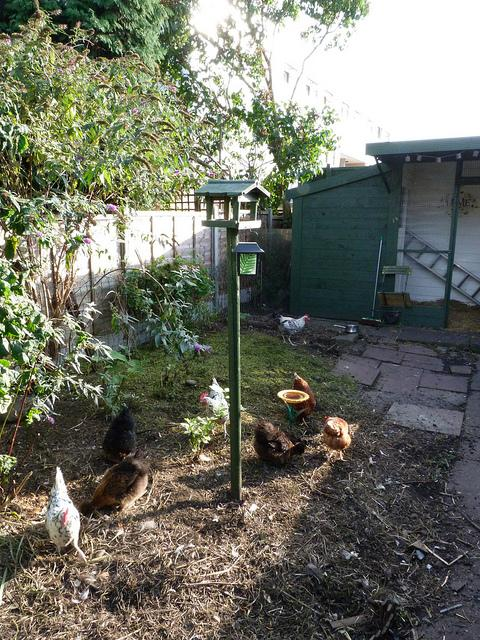How many spotted white chickens are there? Please explain your reasoning. three. There is one by the green part of the house, one by the grass and one in the dirt. 